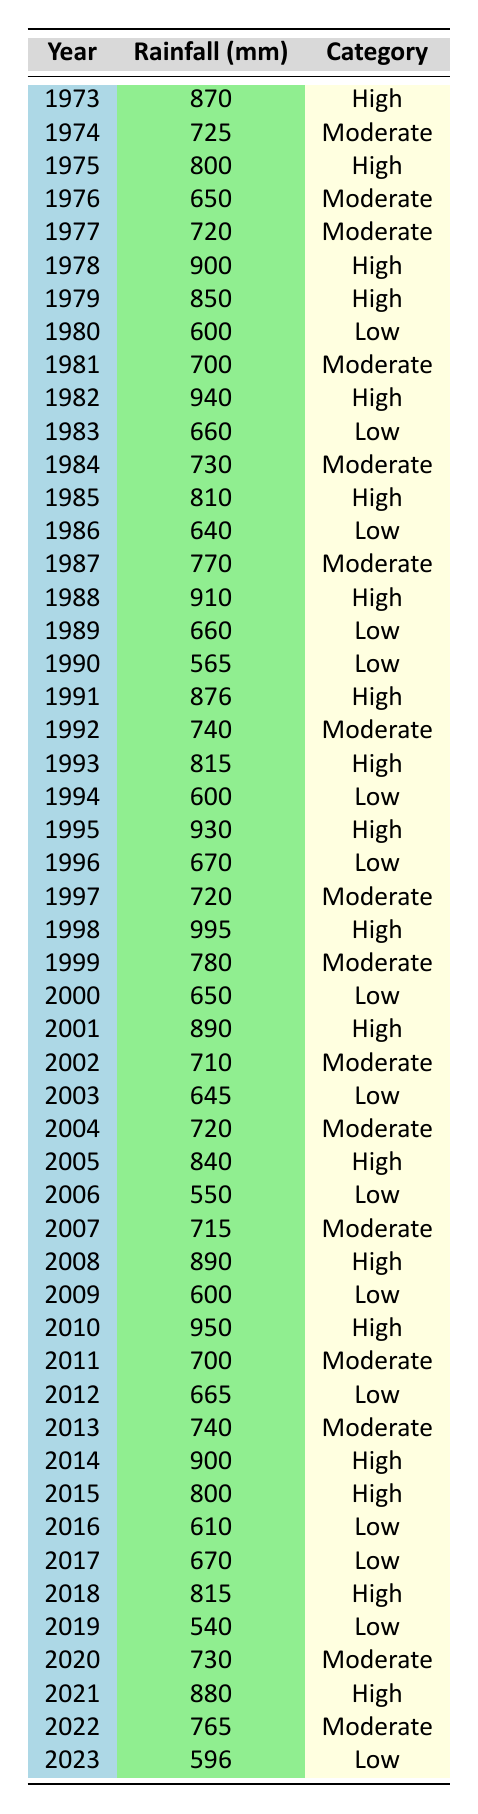What was the highest recorded rainfall in Cihangir over the past 50 years? Looking at the table, I can see that the highest recorded rainfall is 995 mm, which occurred in the year 1998.
Answer: 995 mm In which year did Cihangir experience the lowest rainfall? Referring to the table, the lowest recorded rainfall is 540 mm in the year 2019.
Answer: 540 mm How many years did Cihangir have "High" rainfall? By counting the "High" category in the table, we find that there are 16 occurrences of "High" rainfall over the 50 years listed.
Answer: 16 What was the average rainfall from 2010 to 2020? To calculate the average, I sum up the rainfall from 2010 (950 mm), 2011 (700 mm), 2012 (665 mm), 2013 (740 mm), 2014 (900 mm), 2015 (800 mm), 2016 (610 mm), 2017 (670 mm), 2018 (815 mm), 2019 (540 mm), and 2020 (730 mm), which totals 8,090 mm. Dividing this by 11 years gives me an average of approximately 736.36 mm.
Answer: 736.36 mm Did Cihangir have more "Low" rainfall years than "High" rainfall years? Checking the table, there are 14 years categorized as "Low" and 16 as "High," so no, Cihangir did not have more "Low" rainfall years.
Answer: No What percentage of years had "Moderate" rainfall? In the table, there are 14 years categorized as "Moderate" out of 50 total years. Calculating the percentage involves (14/50) * 100 = 28%.
Answer: 28% In which decade did the most years of "High" rainfall occur? Analyzing the table, I see that from 1980 to 1989, there are 7 years of "High" rainfall, while other decades have fewer. Therefore, the 1980s had the most "High" rainfall years.
Answer: 1980s How much more rainfall did the year 2021 have compared to 2023? The rainfall in 2021 is 880 mm, and in 2023, it is 596 mm. The difference is 880 mm - 596 mm = 284 mm.
Answer: 284 mm 